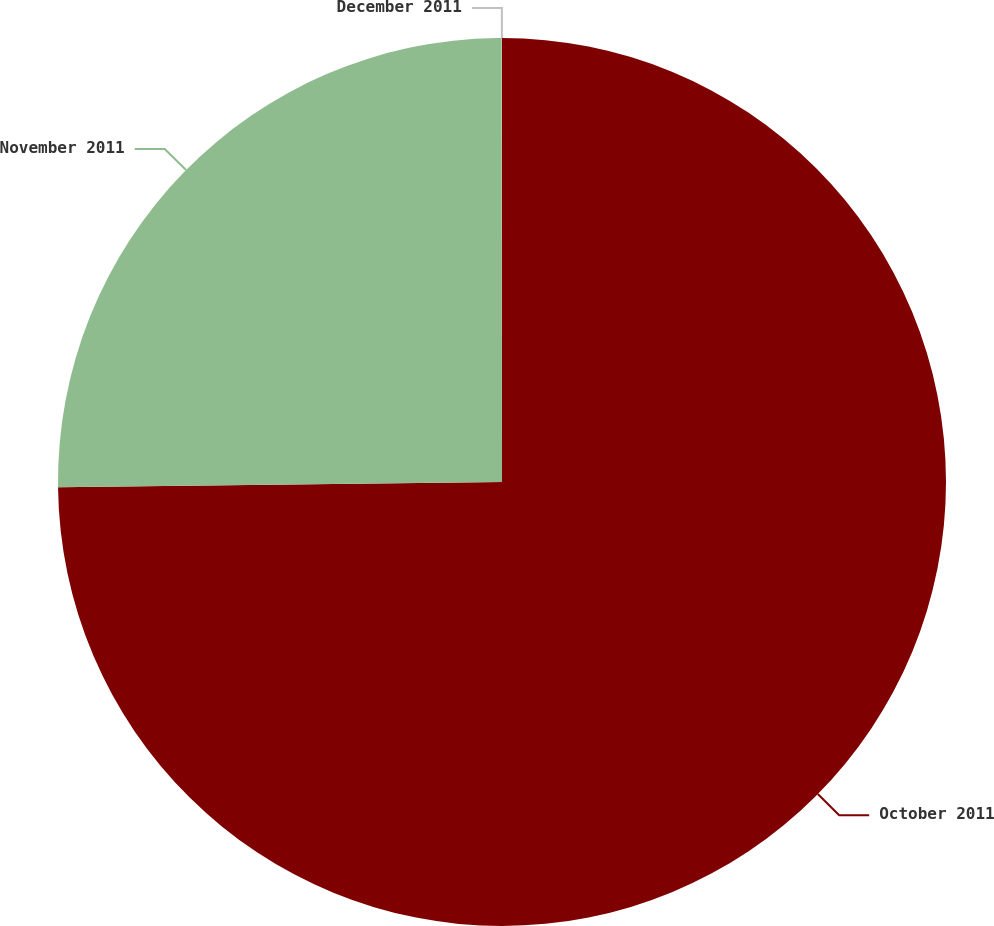Convert chart. <chart><loc_0><loc_0><loc_500><loc_500><pie_chart><fcel>October 2011<fcel>November 2011<fcel>December 2011<nl><fcel>74.81%<fcel>25.18%<fcel>0.01%<nl></chart> 